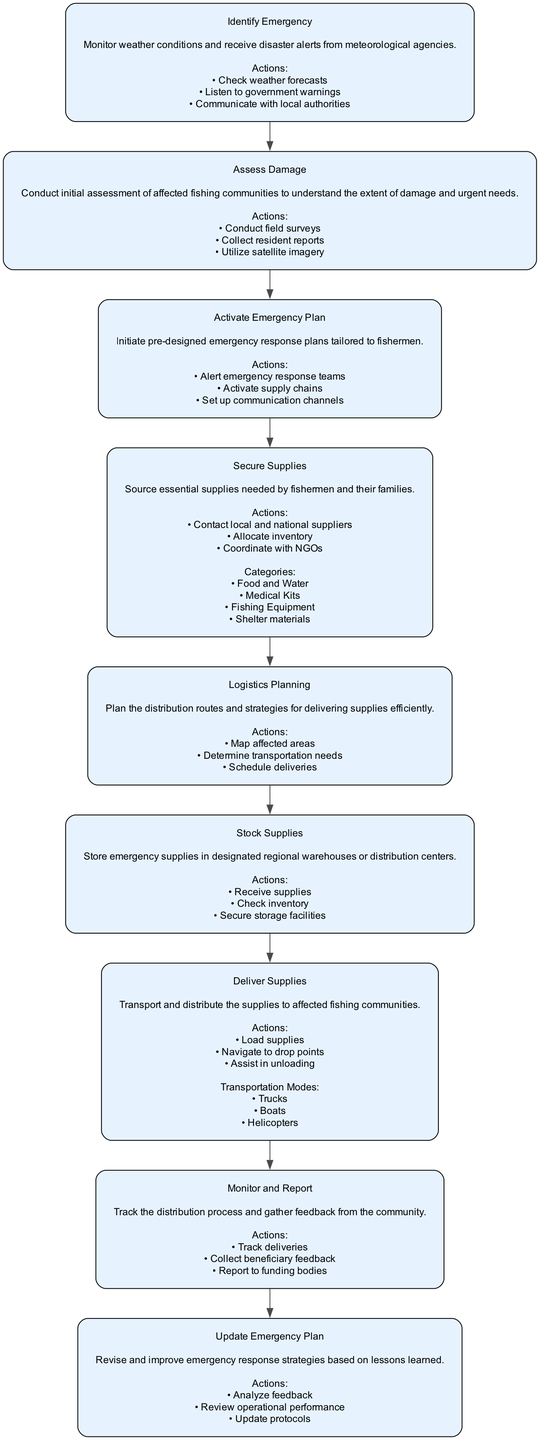What is the first step in the distribution process? The first step outlined in the diagram is "Identify Emergency," which involves monitoring weather conditions and receiving disaster alerts.
Answer: Identify Emergency How many steps are there in total? By counting each step outlined in the flowchart, we see that there are nine distinct steps in the emergency supply distribution process.
Answer: Nine What are the actions listed under "Secure Supplies"? The actions listed under "Secure Supplies" include contacting suppliers, allocating inventory, and coordinating with NGOs.
Answer: Contact local and national suppliers, allocate inventory, coordinate with NGOs Which step comes directly after "Assess Damage"? The step that follows "Assess Damage" is "Activate Emergency Plan," which focuses on initiating pre-designed emergency response measures.
Answer: Activate Emergency Plan What transportation modes are mentioned for delivering supplies? The transportation modes specifically listed in the "Deliver Supplies" step include trucks, boats, and helicopters.
Answer: Trucks, boats, helicopters What category of supplies is not included in the "Secure Supplies" step? The categories listed do not include "Clothing," as the supplies mentioned focus on food and water, medical kits, fishing equipment, and shelter materials.
Answer: Clothing Which step involves gathering feedback from the community? The "Monitor and Report" step is designated for tracking the distribution process and collecting feedback from the affected community.
Answer: Monitor and Report How does the diagram indicate the flow from "Stock Supplies" to "Deliver Supplies"? The flow is indicated by a directed edge connecting the node for "Stock Supplies" to the node for "Deliver Supplies," showing that once supplies are stocked, they move on to delivery.
Answer: Directed edge What is the purpose of "Update Emergency Plan"? The purpose of this step is to revise and improve emergency response strategies based on feedback and operational performance reviews.
Answer: Revise and improve emergency response strategies 